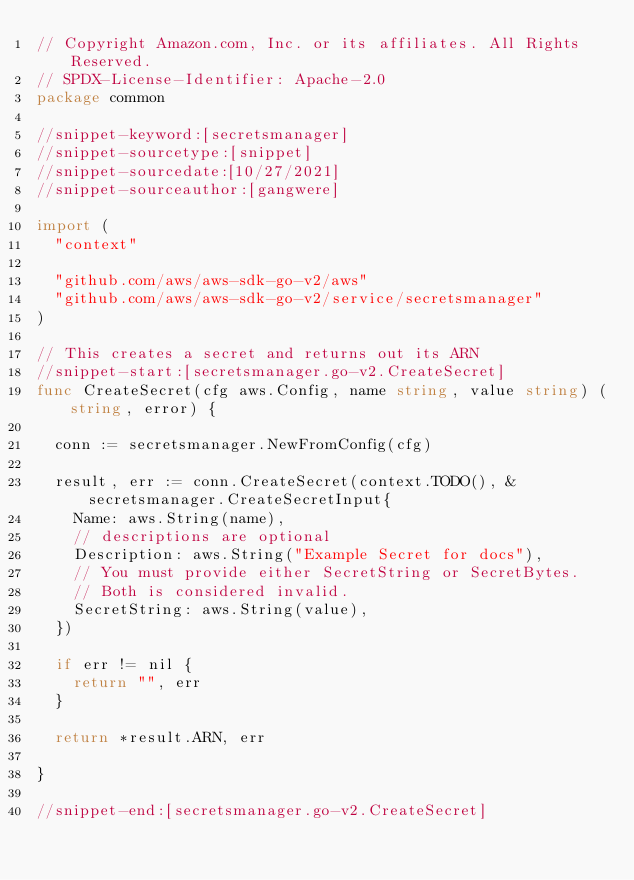Convert code to text. <code><loc_0><loc_0><loc_500><loc_500><_Go_>// Copyright Amazon.com, Inc. or its affiliates. All Rights Reserved.
// SPDX-License-Identifier: Apache-2.0
package common

//snippet-keyword:[secretsmanager]
//snippet-sourcetype:[snippet]
//snippet-sourcedate:[10/27/2021]
//snippet-sourceauthor:[gangwere]

import (
	"context"

	"github.com/aws/aws-sdk-go-v2/aws"
	"github.com/aws/aws-sdk-go-v2/service/secretsmanager"
)

// This creates a secret and returns out its ARN
//snippet-start:[secretsmanager.go-v2.CreateSecret]
func CreateSecret(cfg aws.Config, name string, value string) (string, error) {

	conn := secretsmanager.NewFromConfig(cfg)

	result, err := conn.CreateSecret(context.TODO(), &secretsmanager.CreateSecretInput{
		Name: aws.String(name),
		// descriptions are optional
		Description: aws.String("Example Secret for docs"),
		// You must provide either SecretString or SecretBytes.
		// Both is considered invalid.
		SecretString: aws.String(value),
	})

	if err != nil {
		return "", err
	}

	return *result.ARN, err

}

//snippet-end:[secretsmanager.go-v2.CreateSecret]
</code> 